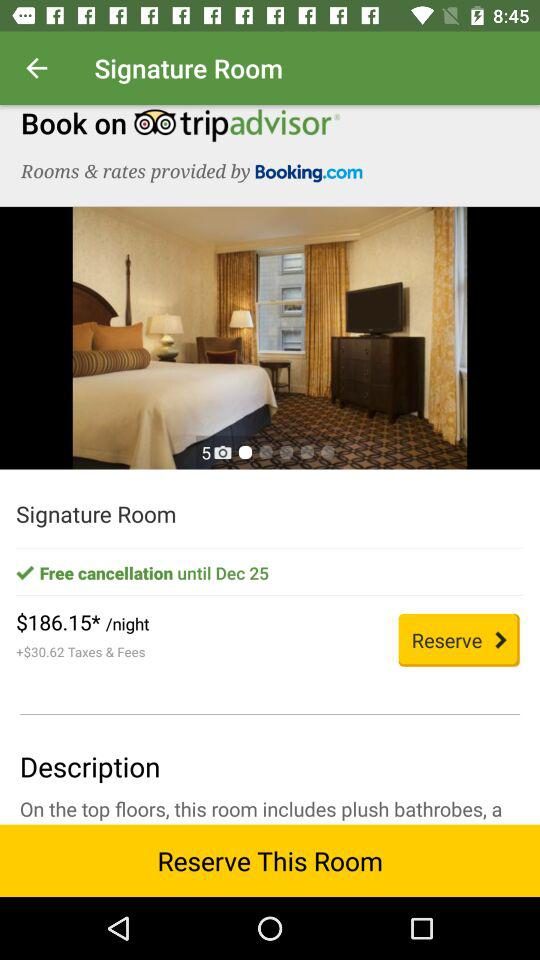How many photos are there of the room? There are five photos of the room. 